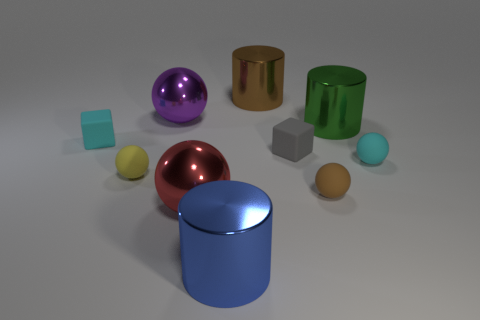Are the small yellow ball and the big brown thing made of the same material? While the image does not provide definitive information about the material composition, based on the appearances of the objects, it is unlikely that the small yellow ball and the large brown object are made of the same material. The small yellow ball has a smooth, shiny surface that could suggest a plastic or a glossy painted finish, whereas the big brown object, which resembles a cylinder, appears to have a different texture that might be indicative of metal or wood. 